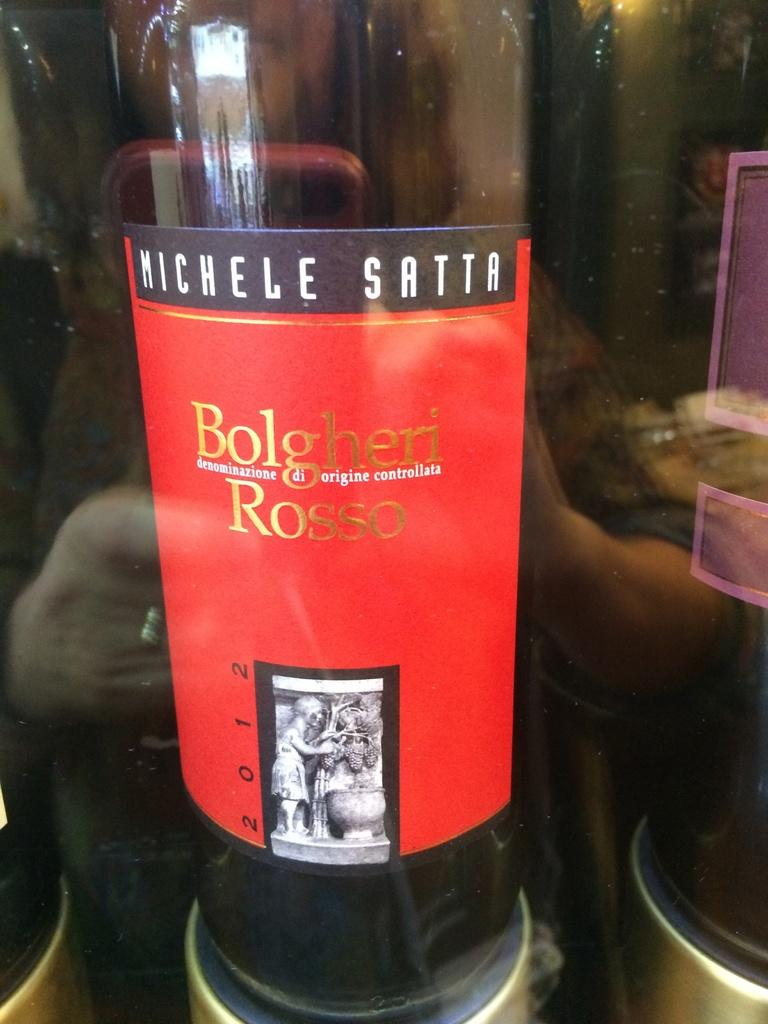<image>
Share a concise interpretation of the image provided. A bottle of Bolgheri Rosso wine placed behind a glass. 